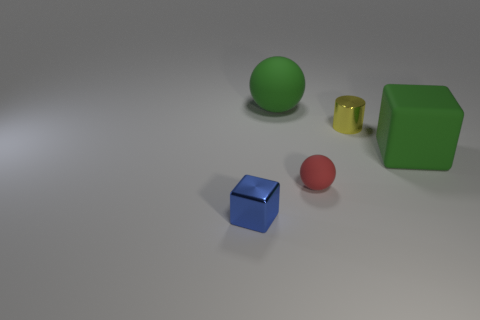There is a matte thing that is behind the green block; what is its shape?
Provide a short and direct response. Sphere. Does the small blue shiny thing have the same shape as the tiny object that is behind the large green matte block?
Provide a succinct answer. No. What is the size of the object that is to the left of the yellow object and behind the large block?
Your answer should be very brief. Large. What is the color of the thing that is both behind the small blue cube and in front of the green rubber block?
Your response must be concise. Red. Is there anything else that is the same material as the tiny yellow cylinder?
Ensure brevity in your answer.  Yes. Is the number of spheres that are behind the small ball less than the number of metallic things that are to the right of the yellow cylinder?
Offer a terse response. No. Is there any other thing that is the same color as the cylinder?
Give a very brief answer. No. What is the shape of the small yellow metallic thing?
Offer a very short reply. Cylinder. There is a small thing that is made of the same material as the cylinder; what color is it?
Your response must be concise. Blue. Are there more matte objects than rubber balls?
Keep it short and to the point. Yes. 